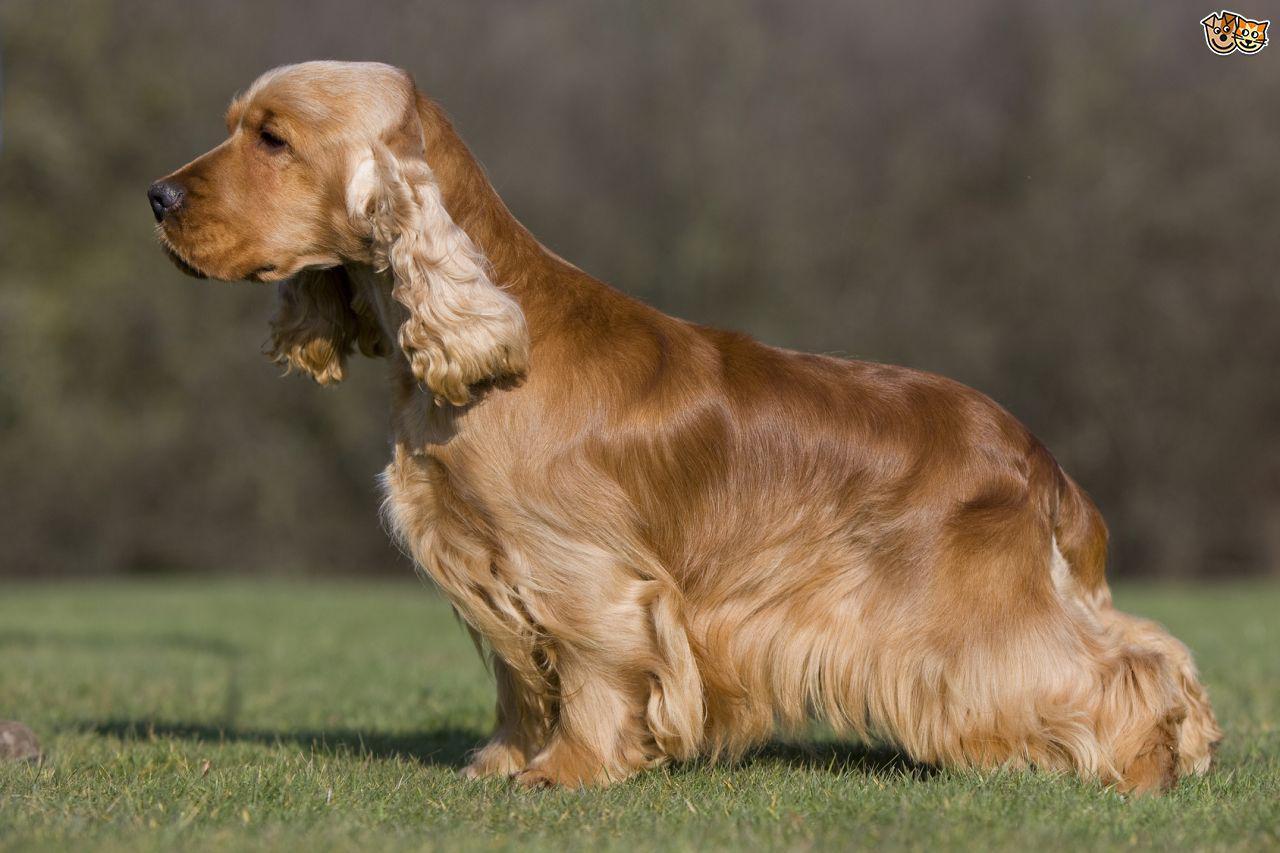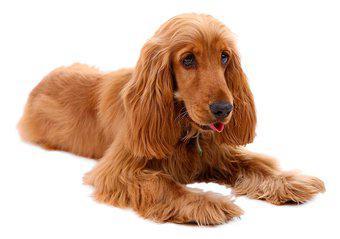The first image is the image on the left, the second image is the image on the right. For the images shown, is this caption "There is at least one dog against a plain white background in the image on the left." true? Answer yes or no. No. The first image is the image on the left, the second image is the image on the right. Analyze the images presented: Is the assertion "A dog is standing on all fours in one of the images" valid? Answer yes or no. Yes. 